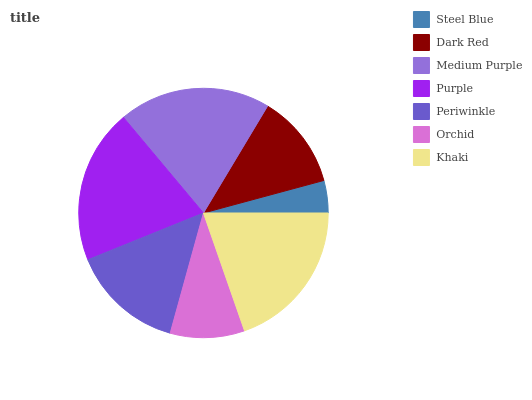Is Steel Blue the minimum?
Answer yes or no. Yes. Is Purple the maximum?
Answer yes or no. Yes. Is Dark Red the minimum?
Answer yes or no. No. Is Dark Red the maximum?
Answer yes or no. No. Is Dark Red greater than Steel Blue?
Answer yes or no. Yes. Is Steel Blue less than Dark Red?
Answer yes or no. Yes. Is Steel Blue greater than Dark Red?
Answer yes or no. No. Is Dark Red less than Steel Blue?
Answer yes or no. No. Is Periwinkle the high median?
Answer yes or no. Yes. Is Periwinkle the low median?
Answer yes or no. Yes. Is Orchid the high median?
Answer yes or no. No. Is Medium Purple the low median?
Answer yes or no. No. 